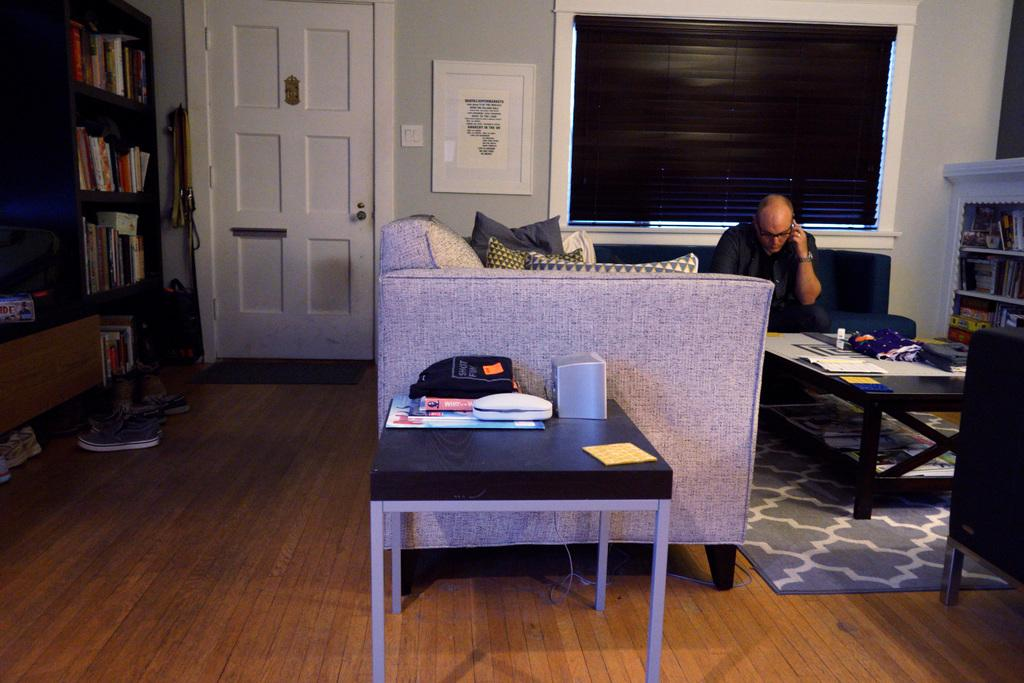What is the man in the image doing? The man is seated on a sofa in the image. What is the man holding in his hand? The man is holding a mobile in his hand. What type of furniture can be seen in the image? There is a bookshelf, a door, shoes, a table, and papers visible in the image. Can you describe the man's surroundings? The man is seated on a sofa in a room with a bookshelf, a door, shoes, a table, and papers. What type of vegetable is the man eating in the image? There is no vegetable present in the image; the man is holding a mobile in his hand. 